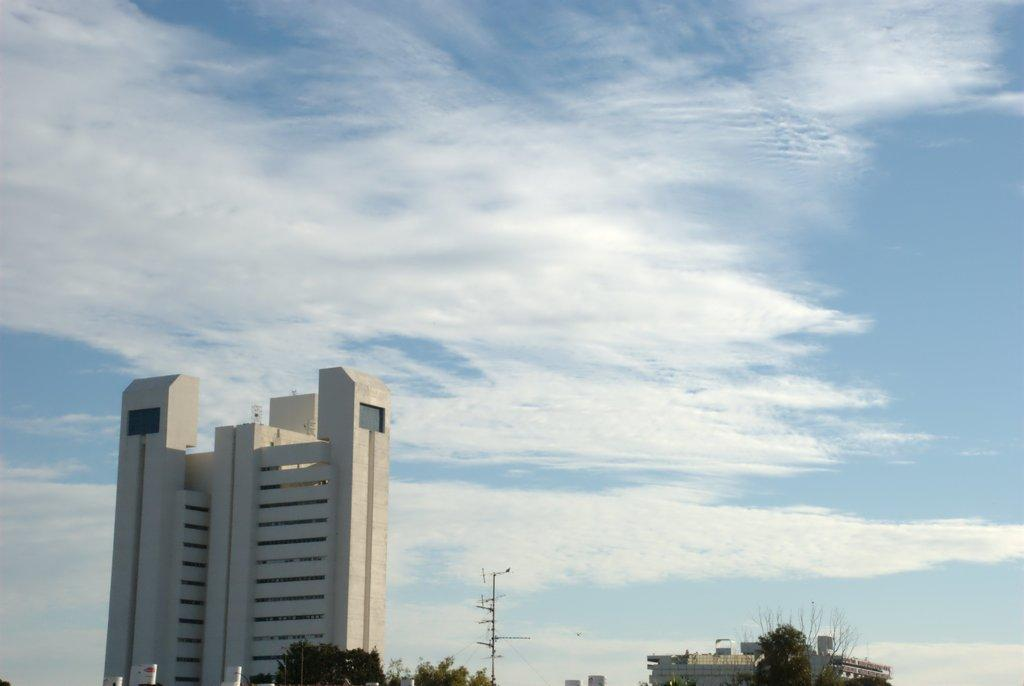What type of vegetation can be seen in the image? There are trees in the image. What structure is present in the image besides the trees? There is a pole and a building in the image. What is the color of the building in the image? The building is cream in color. What can be seen in the background of the image? The sky is visible in the background of the image. Can you tell me how many baseballs are on the pole in the image? There are no baseballs present in the image; it features trees, a pole, a building, and the sky. What type of office is located inside the cream-colored building in the image? There is no information about an office or any interior details of the building in the image. 